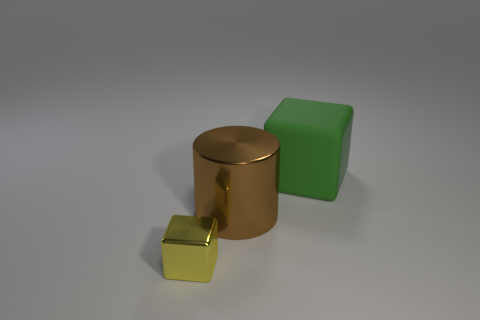There is a block that is in front of the rubber object; is it the same color as the cylinder?
Give a very brief answer. No. How many cubes are either large brown rubber things or rubber things?
Offer a very short reply. 1. The big thing in front of the green rubber cube has what shape?
Your answer should be very brief. Cylinder. There is a block that is in front of the cube behind the block that is on the left side of the green cube; what color is it?
Provide a succinct answer. Yellow. Do the yellow object and the large green object have the same material?
Make the answer very short. No. What number of yellow objects are big rubber things or small objects?
Give a very brief answer. 1. What number of green matte things are to the left of the large green matte thing?
Give a very brief answer. 0. Is the number of big brown objects greater than the number of red blocks?
Keep it short and to the point. Yes. What is the shape of the big object that is to the right of the big object that is to the left of the large cube?
Your answer should be very brief. Cube. Are there more objects that are on the right side of the large brown shiny object than cyan shiny cylinders?
Your answer should be very brief. Yes. 